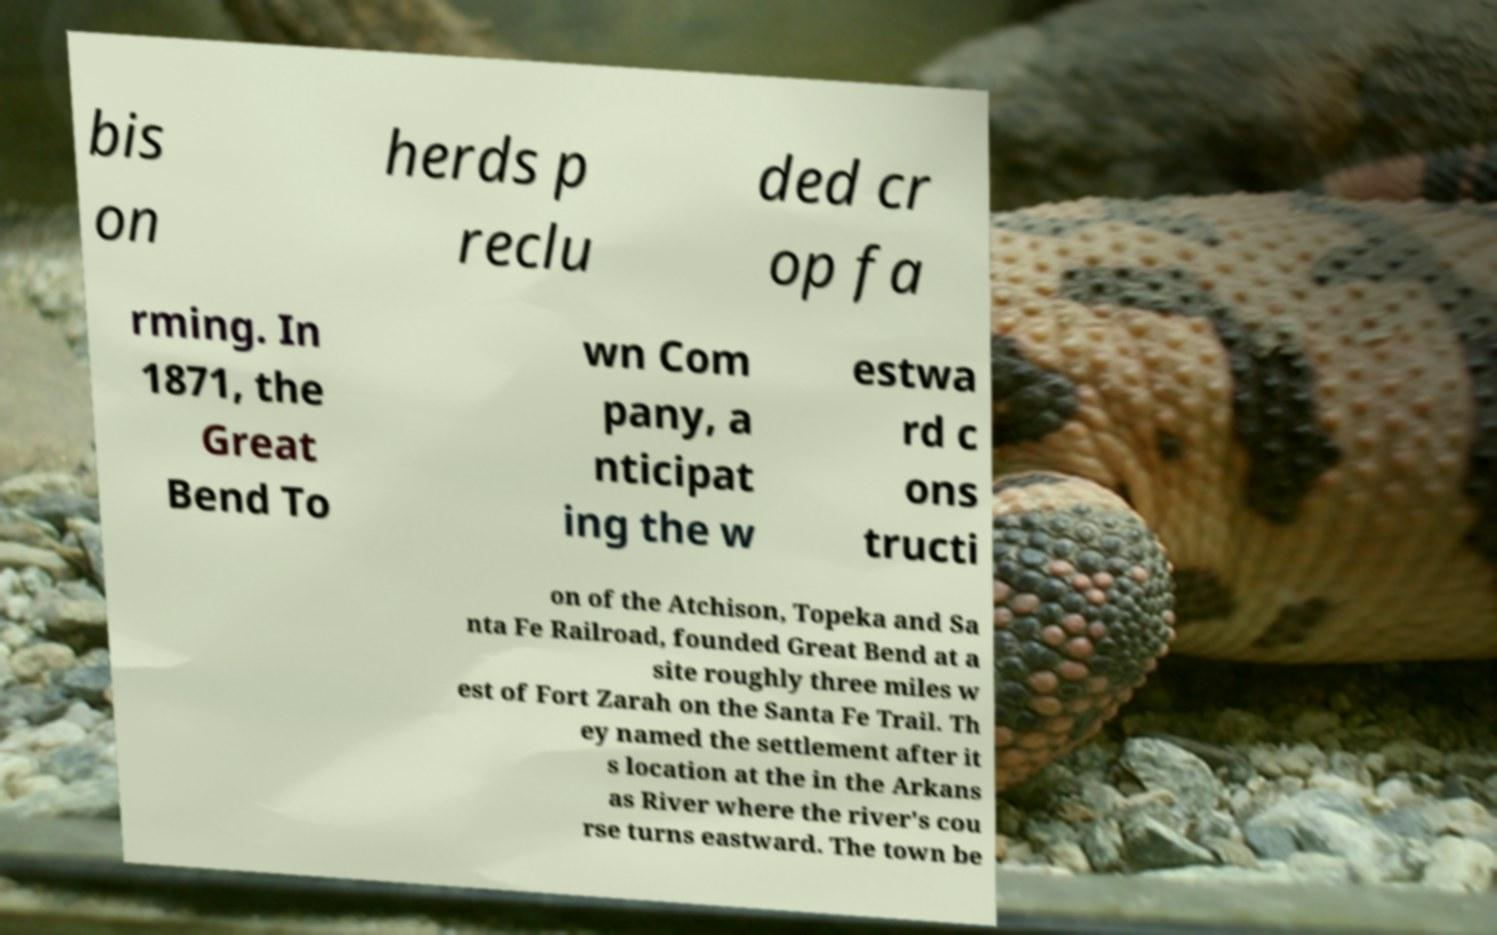Please read and relay the text visible in this image. What does it say? bis on herds p reclu ded cr op fa rming. In 1871, the Great Bend To wn Com pany, a nticipat ing the w estwa rd c ons tructi on of the Atchison, Topeka and Sa nta Fe Railroad, founded Great Bend at a site roughly three miles w est of Fort Zarah on the Santa Fe Trail. Th ey named the settlement after it s location at the in the Arkans as River where the river's cou rse turns eastward. The town be 